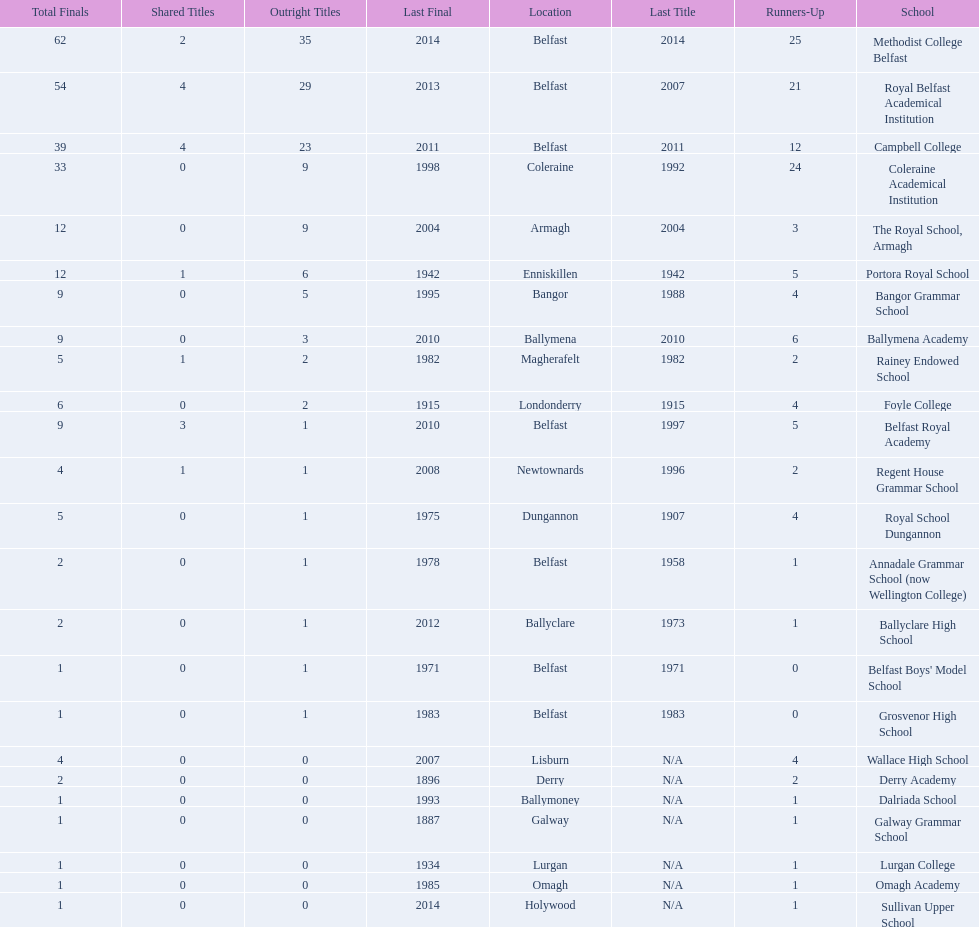What were all of the school names? Methodist College Belfast, Royal Belfast Academical Institution, Campbell College, Coleraine Academical Institution, The Royal School, Armagh, Portora Royal School, Bangor Grammar School, Ballymena Academy, Rainey Endowed School, Foyle College, Belfast Royal Academy, Regent House Grammar School, Royal School Dungannon, Annadale Grammar School (now Wellington College), Ballyclare High School, Belfast Boys' Model School, Grosvenor High School, Wallace High School, Derry Academy, Dalriada School, Galway Grammar School, Lurgan College, Omagh Academy, Sullivan Upper School. How many outright titles did they achieve? 35, 29, 23, 9, 9, 6, 5, 3, 2, 2, 1, 1, 1, 1, 1, 1, 1, 0, 0, 0, 0, 0, 0, 0. And how many did coleraine academical institution receive? 9. Which other school had the same number of outright titles? The Royal School, Armagh. 